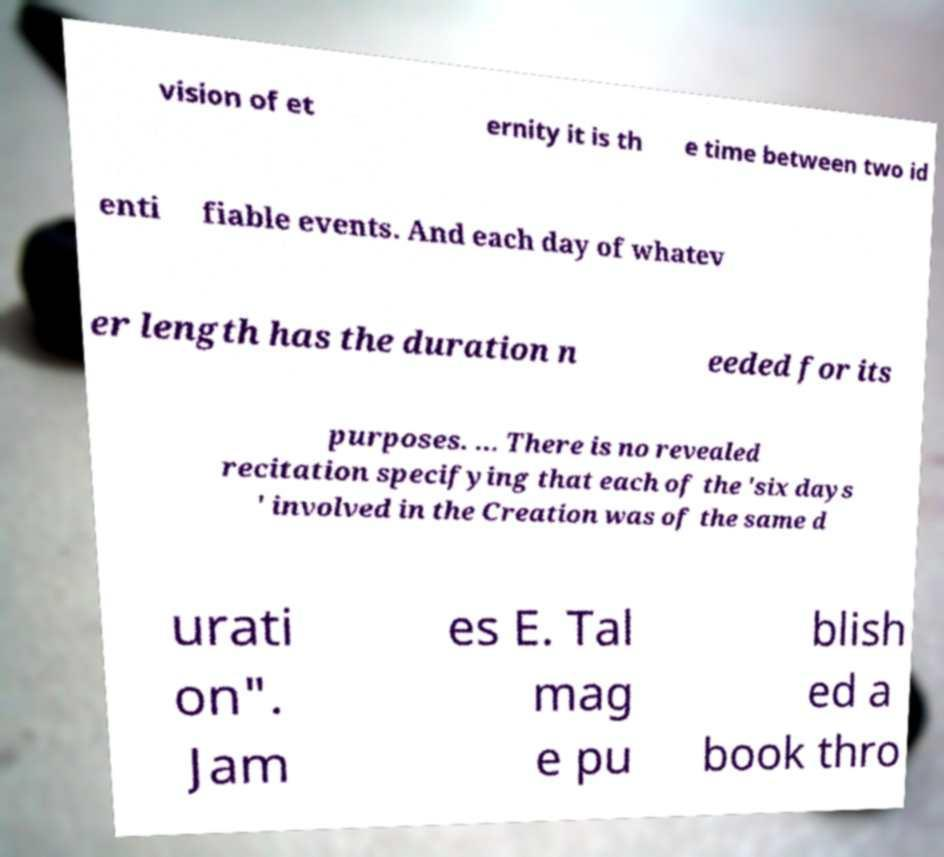I need the written content from this picture converted into text. Can you do that? vision of et ernity it is th e time between two id enti fiable events. And each day of whatev er length has the duration n eeded for its purposes. ... There is no revealed recitation specifying that each of the 'six days ' involved in the Creation was of the same d urati on". Jam es E. Tal mag e pu blish ed a book thro 